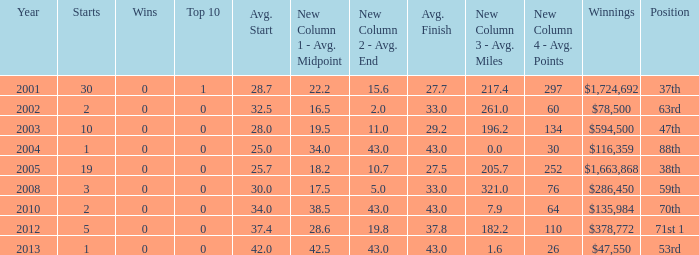How many starts for an average finish greater than 43? None. 